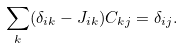Convert formula to latex. <formula><loc_0><loc_0><loc_500><loc_500>\sum _ { k } ( \delta _ { i k } - J _ { i k } ) C _ { k j } = \delta _ { i j } .</formula> 